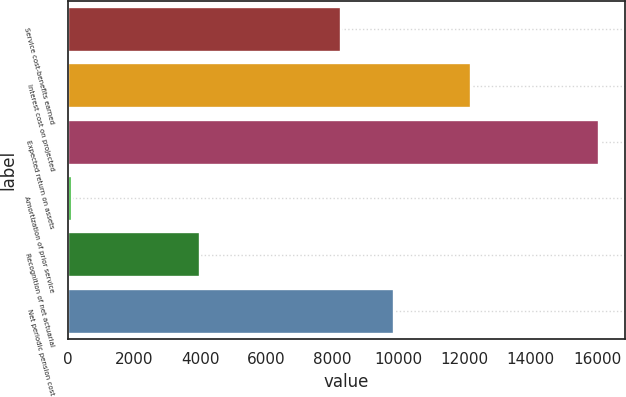Convert chart to OTSL. <chart><loc_0><loc_0><loc_500><loc_500><bar_chart><fcel>Service cost-benefits earned<fcel>Interest cost on projected<fcel>Expected return on assets<fcel>Amortization of prior service<fcel>Recognition of net actuarial<fcel>Net periodic pension cost<nl><fcel>8270<fcel>12200<fcel>16055<fcel>118<fcel>3981<fcel>9863.7<nl></chart> 